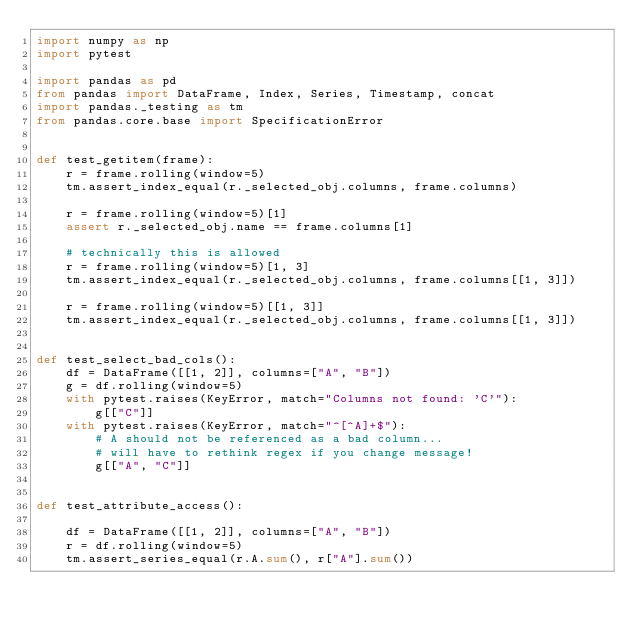Convert code to text. <code><loc_0><loc_0><loc_500><loc_500><_Python_>import numpy as np
import pytest

import pandas as pd
from pandas import DataFrame, Index, Series, Timestamp, concat
import pandas._testing as tm
from pandas.core.base import SpecificationError


def test_getitem(frame):
    r = frame.rolling(window=5)
    tm.assert_index_equal(r._selected_obj.columns, frame.columns)

    r = frame.rolling(window=5)[1]
    assert r._selected_obj.name == frame.columns[1]

    # technically this is allowed
    r = frame.rolling(window=5)[1, 3]
    tm.assert_index_equal(r._selected_obj.columns, frame.columns[[1, 3]])

    r = frame.rolling(window=5)[[1, 3]]
    tm.assert_index_equal(r._selected_obj.columns, frame.columns[[1, 3]])


def test_select_bad_cols():
    df = DataFrame([[1, 2]], columns=["A", "B"])
    g = df.rolling(window=5)
    with pytest.raises(KeyError, match="Columns not found: 'C'"):
        g[["C"]]
    with pytest.raises(KeyError, match="^[^A]+$"):
        # A should not be referenced as a bad column...
        # will have to rethink regex if you change message!
        g[["A", "C"]]


def test_attribute_access():

    df = DataFrame([[1, 2]], columns=["A", "B"])
    r = df.rolling(window=5)
    tm.assert_series_equal(r.A.sum(), r["A"].sum())</code> 